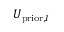<formula> <loc_0><loc_0><loc_500><loc_500>U _ { p r i o r , I }</formula> 